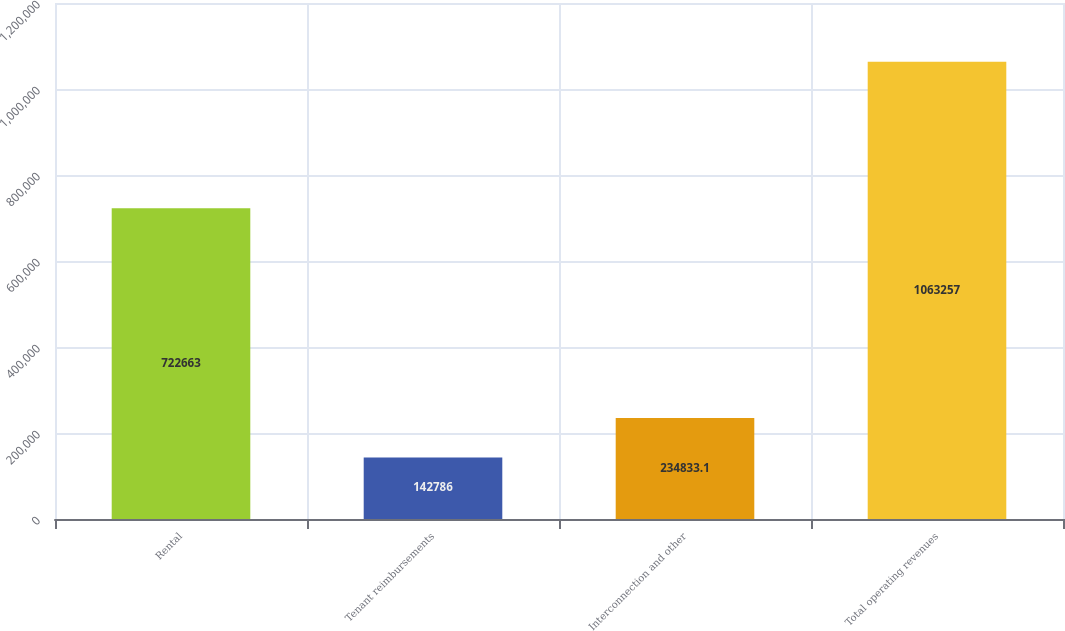Convert chart to OTSL. <chart><loc_0><loc_0><loc_500><loc_500><bar_chart><fcel>Rental<fcel>Tenant reimbursements<fcel>Interconnection and other<fcel>Total operating revenues<nl><fcel>722663<fcel>142786<fcel>234833<fcel>1.06326e+06<nl></chart> 